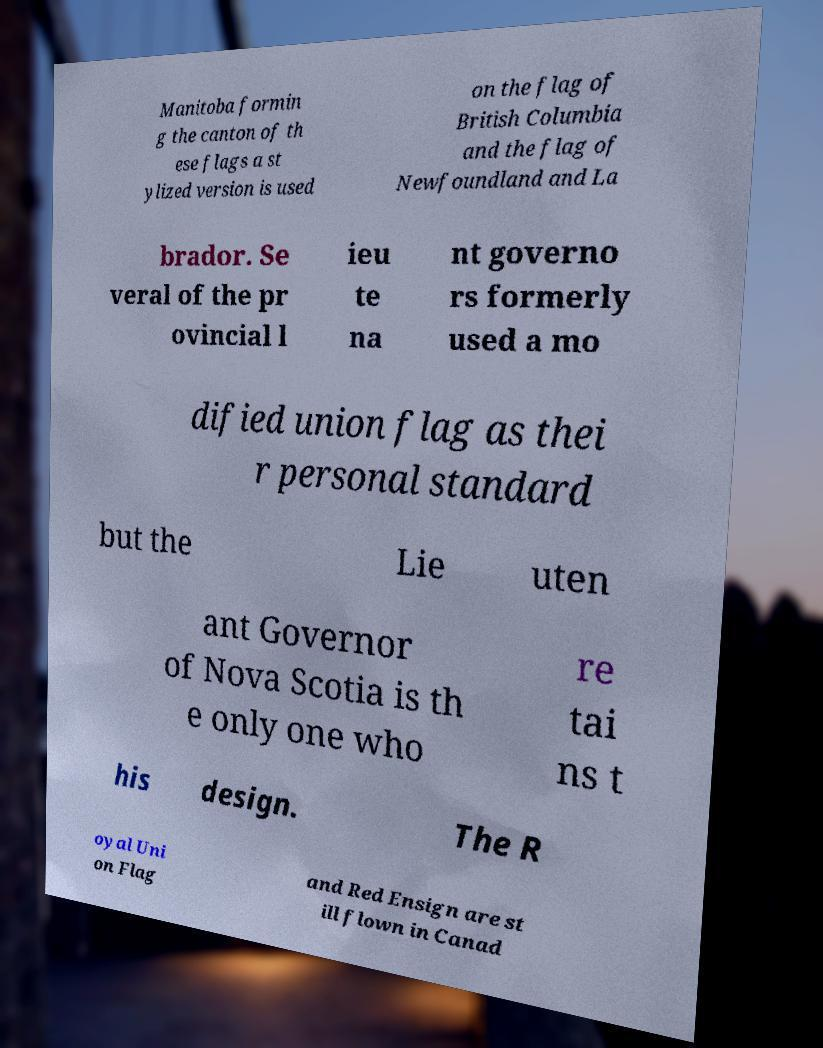Can you read and provide the text displayed in the image?This photo seems to have some interesting text. Can you extract and type it out for me? Manitoba formin g the canton of th ese flags a st ylized version is used on the flag of British Columbia and the flag of Newfoundland and La brador. Se veral of the pr ovincial l ieu te na nt governo rs formerly used a mo dified union flag as thei r personal standard but the Lie uten ant Governor of Nova Scotia is th e only one who re tai ns t his design. The R oyal Uni on Flag and Red Ensign are st ill flown in Canad 